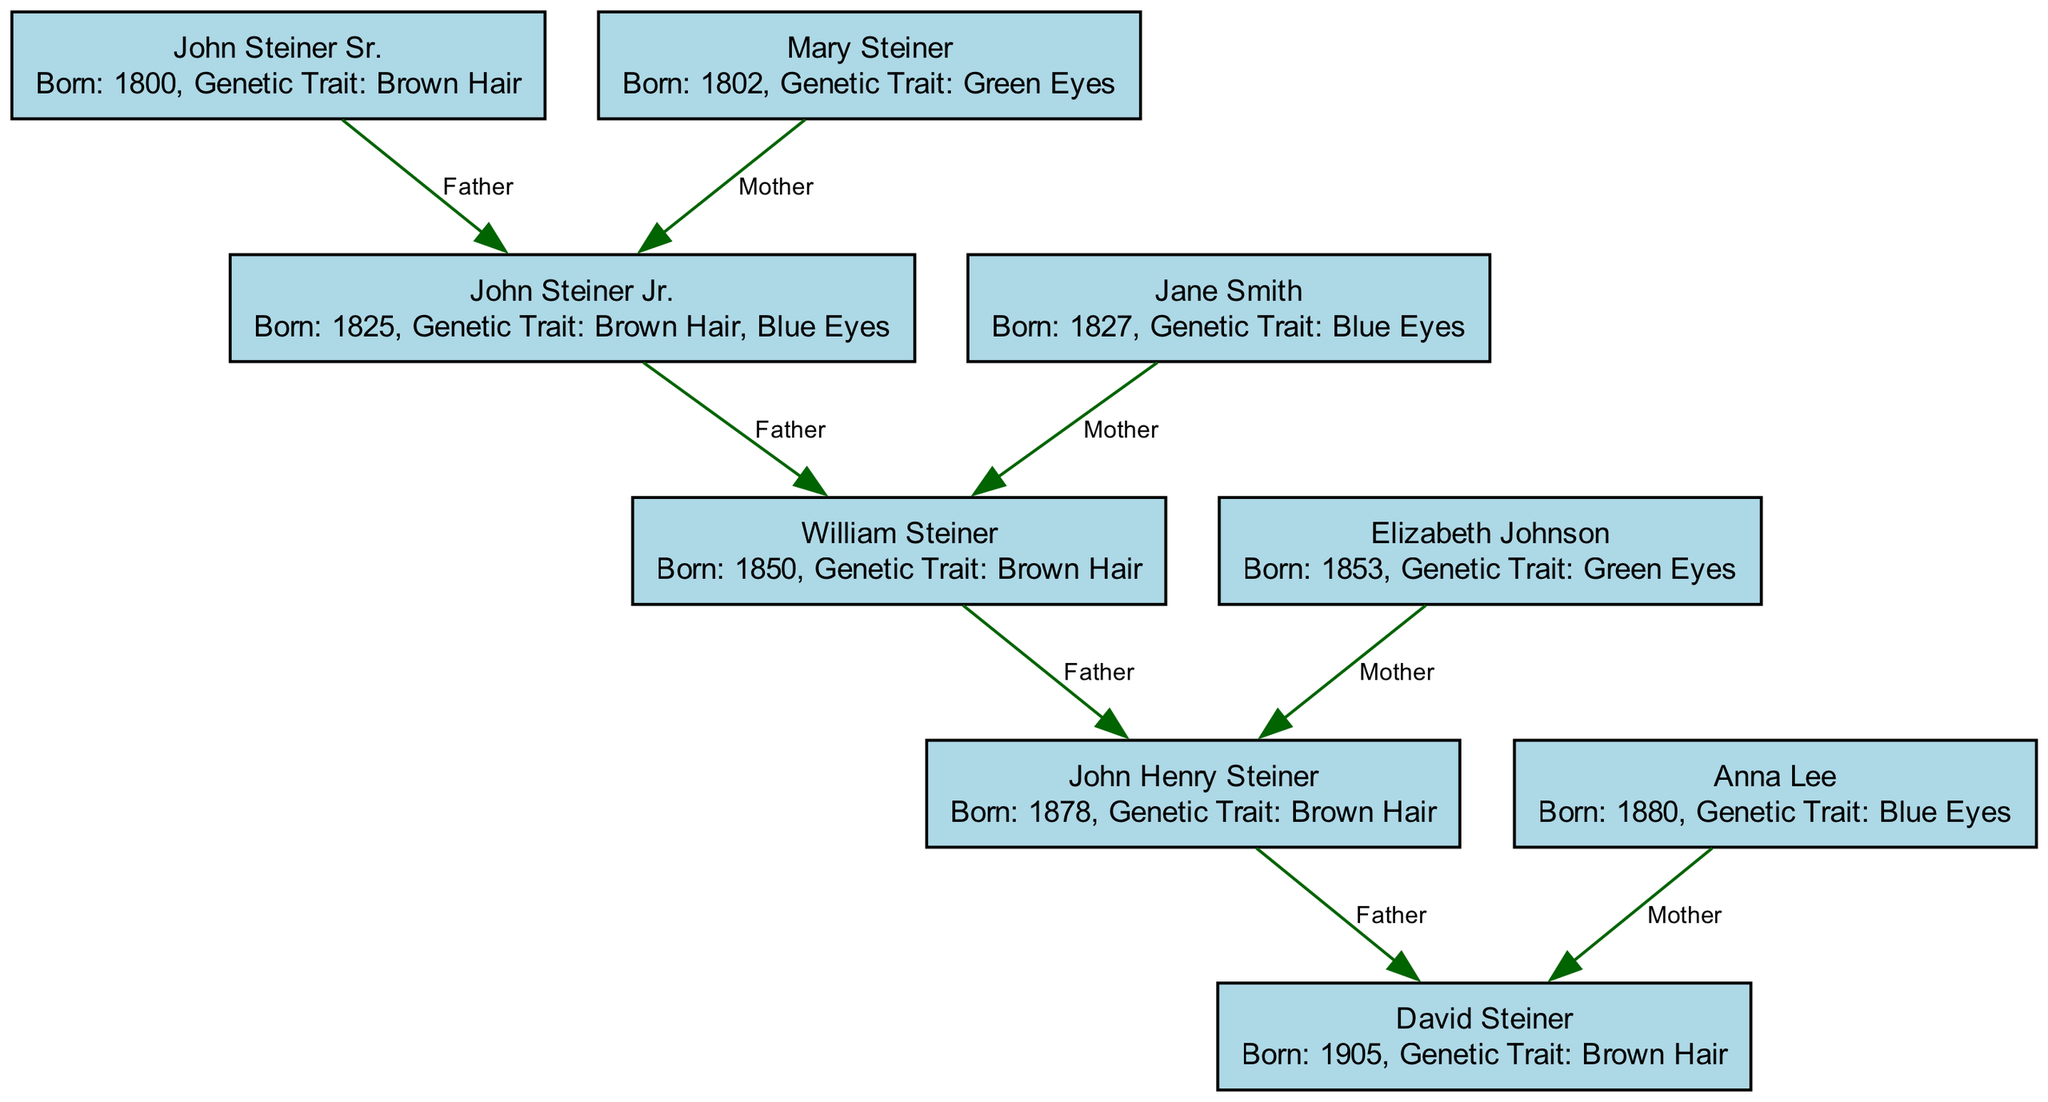What is the genetic trait of John Steiner Sr.? According to the diagram, John Steiner Sr. has the genetic trait of brown hair, which is stated in the description of the node representing him.
Answer: Brown Hair Who is the mother of John Henry Steiner? By following the edges connected to John Henry Steiner, we find that his mother is Elizabeth Johnson. This is indicated directly by the edge that connects Elizabeth Johnson to John Henry Steiner with the label "Mother."
Answer: Elizabeth Johnson How many individuals in the diagram have brown hair? To determine the count of individuals with brown hair, we can scan through the descriptions of all nodes. John Steiner Sr., John Steiner Jr., John Henry Steiner, and David Steiner all have brown hair, resulting in a total of four individuals.
Answer: 4 What is the relationship between John Steiner Jr. and William Steiner? The diagram shows that John Steiner Jr. is the father of William Steiner. This is evidenced by the directional edge from John Steiner Jr. to William Steiner labeled "Father."
Answer: Father Which individual has green eyes? Examining the descriptions in the nodes, Mary Steiner and Elizabeth Johnson both have the genetic trait of green eyes. Thus, the answer could refer to either of them, but since the question generally aims to identify an individual, the first instance provided is Mary Steiner.
Answer: Mary Steiner How many nodes are present in the diagram? The total number of nodes can be identified by counting each individual represented. In this case, there are a total of eight nodes listed in the node section of the data.
Answer: 8 Which John Steiner descendant is born in 1905? Looking at the nodes, David Steiner is listed as being born in 1905. This is a specific detail provided within the description of the node.
Answer: David Steiner What is the genetic trait of Anna Lee? The description associated with the node of Anna Lee indicates that she has blue eyes. This information is directly stated in her node.
Answer: Blue Eyes 